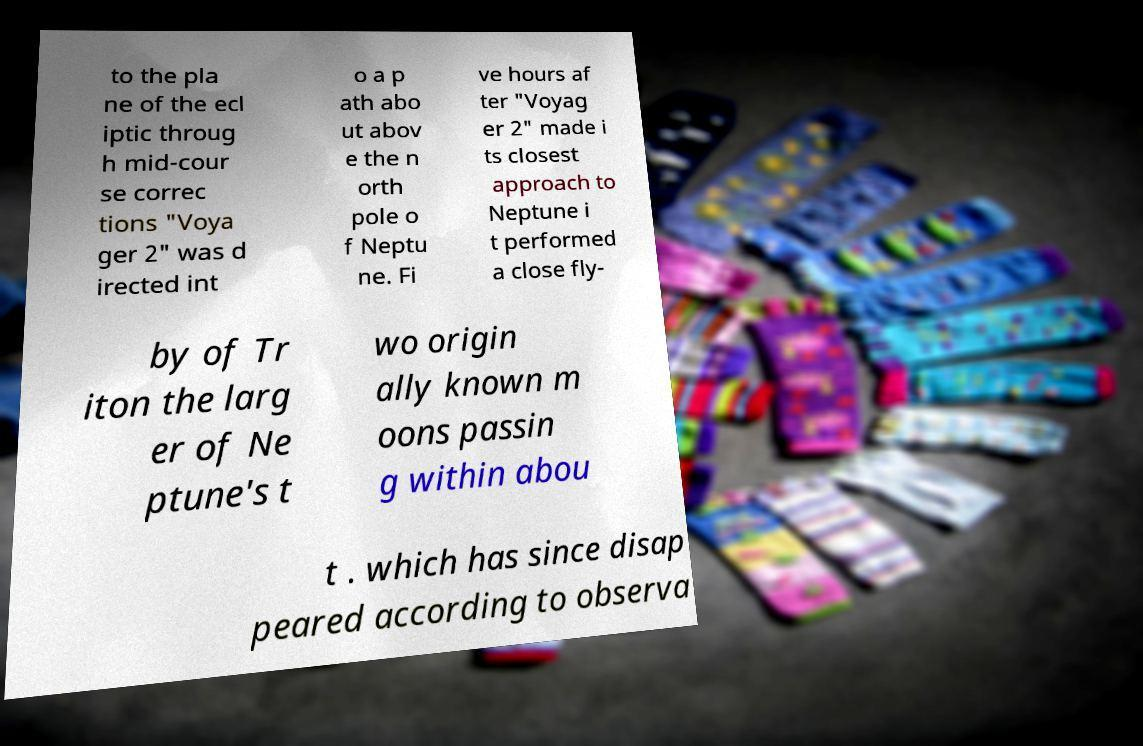Could you assist in decoding the text presented in this image and type it out clearly? to the pla ne of the ecl iptic throug h mid-cour se correc tions "Voya ger 2" was d irected int o a p ath abo ut abov e the n orth pole o f Neptu ne. Fi ve hours af ter "Voyag er 2" made i ts closest approach to Neptune i t performed a close fly- by of Tr iton the larg er of Ne ptune's t wo origin ally known m oons passin g within abou t . which has since disap peared according to observa 